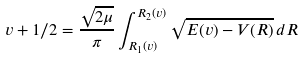<formula> <loc_0><loc_0><loc_500><loc_500>v + 1 / 2 = \frac { \sqrt { 2 \mu } } { \pi } \int _ { R _ { 1 } ( v ) } ^ { R _ { 2 } ( v ) } \sqrt { E ( v ) - V ( R ) } \, d R</formula> 